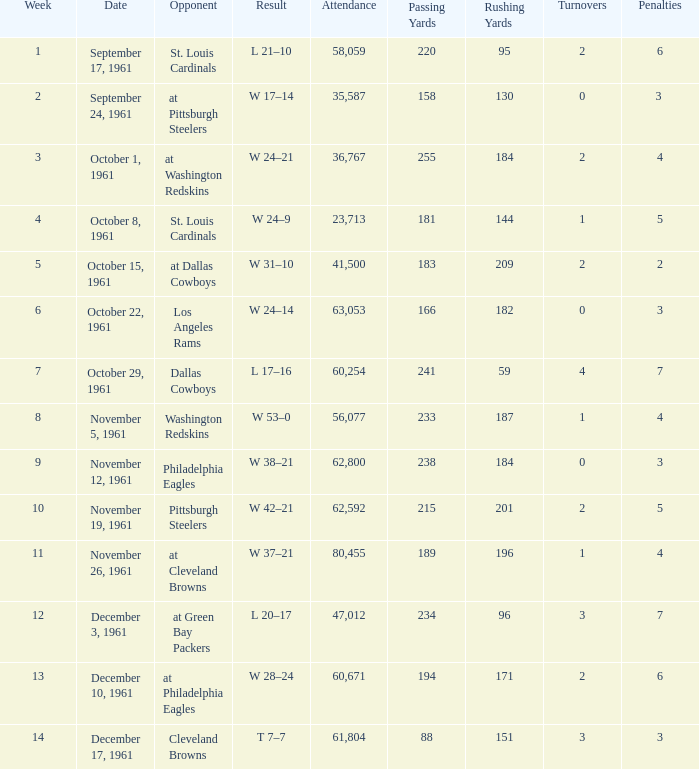Which Week has an Opponent of washington redskins, and an Attendance larger than 56,077? 0.0. I'm looking to parse the entire table for insights. Could you assist me with that? {'header': ['Week', 'Date', 'Opponent', 'Result', 'Attendance', 'Passing Yards', 'Rushing Yards', 'Turnovers', 'Penalties'], 'rows': [['1', 'September 17, 1961', 'St. Louis Cardinals', 'L 21–10', '58,059', '220', '95', '2', '6'], ['2', 'September 24, 1961', 'at Pittsburgh Steelers', 'W 17–14', '35,587', '158', '130', '0', '3 '], ['3', 'October 1, 1961', 'at Washington Redskins', 'W 24–21', '36,767', '255', '184', '2', '4'], ['4', 'October 8, 1961', 'St. Louis Cardinals', 'W 24–9', '23,713', '181', '144', '1', '5'], ['5', 'October 15, 1961', 'at Dallas Cowboys', 'W 31–10', '41,500', '183', '209', '2', '2'], ['6', 'October 22, 1961', 'Los Angeles Rams', 'W 24–14', '63,053', '166', '182', '0', '3'], ['7', 'October 29, 1961', 'Dallas Cowboys', 'L 17–16', '60,254', '241', '59', '4', '7'], ['8', 'November 5, 1961', 'Washington Redskins', 'W 53–0', '56,077', '233', '187', '1', '4'], ['9', 'November 12, 1961', 'Philadelphia Eagles', 'W 38–21', '62,800', '238', '184', '0', '3'], ['10', 'November 19, 1961', 'Pittsburgh Steelers', 'W 42–21', '62,592', '215', '201', '2', '5'], ['11', 'November 26, 1961', 'at Cleveland Browns', 'W 37–21', '80,455', '189', '196', '1', '4'], ['12', 'December 3, 1961', 'at Green Bay Packers', 'L 20–17', '47,012', '234', '96', '3', '7'], ['13', 'December 10, 1961', 'at Philadelphia Eagles', 'W 28–24', '60,671', '194', '171', '2', '6'], ['14', 'December 17, 1961', 'Cleveland Browns', 'T 7–7', '61,804', '88', '151', '3', '3']]} 